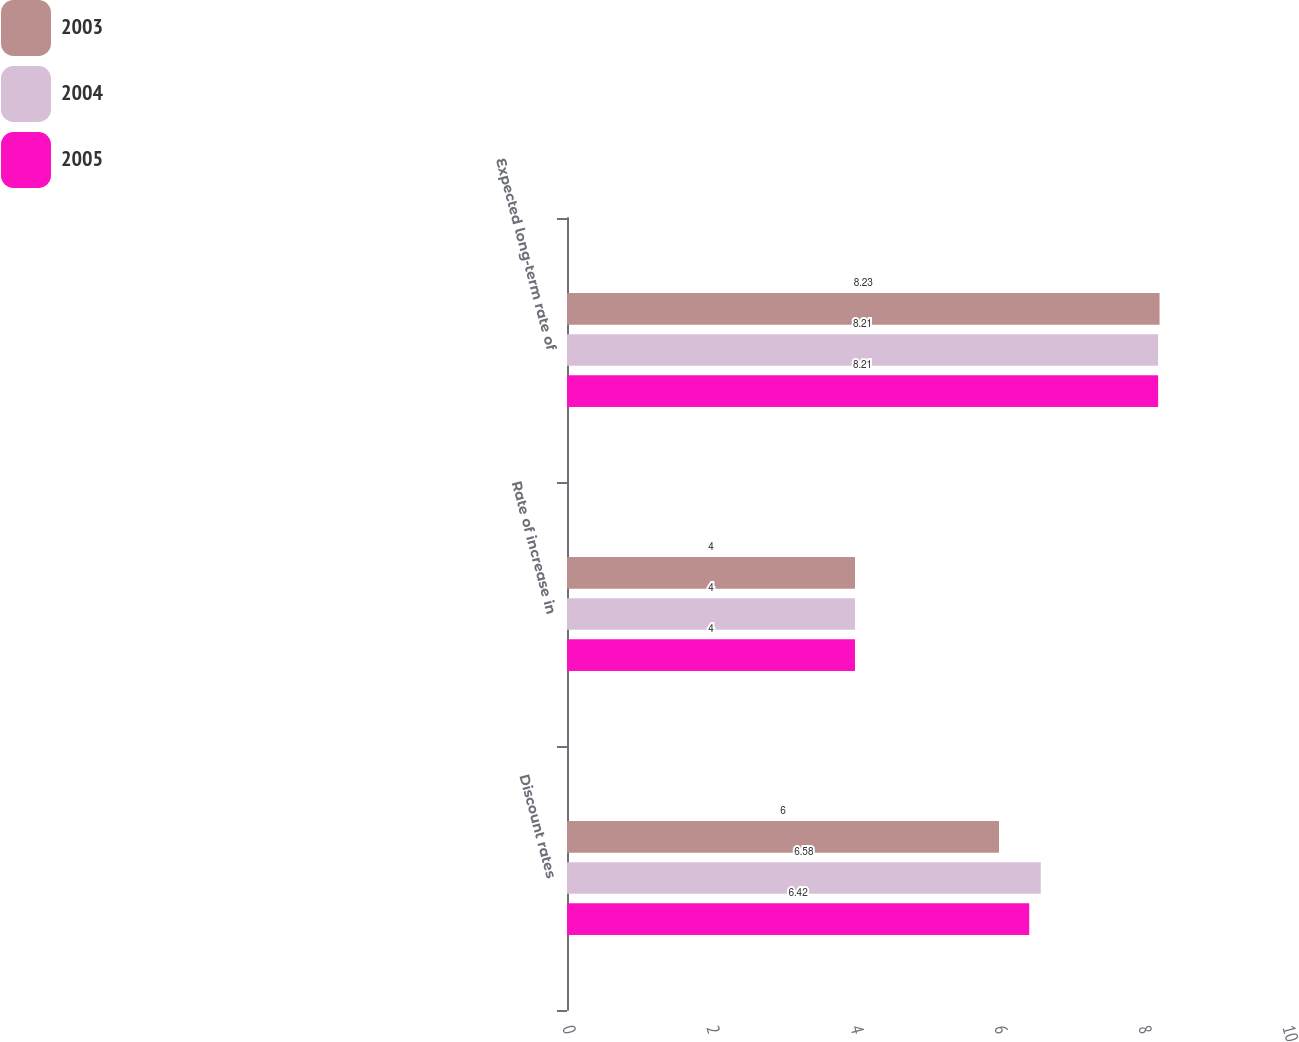Convert chart. <chart><loc_0><loc_0><loc_500><loc_500><stacked_bar_chart><ecel><fcel>Discount rates<fcel>Rate of increase in<fcel>Expected long-term rate of<nl><fcel>2003<fcel>6<fcel>4<fcel>8.23<nl><fcel>2004<fcel>6.58<fcel>4<fcel>8.21<nl><fcel>2005<fcel>6.42<fcel>4<fcel>8.21<nl></chart> 